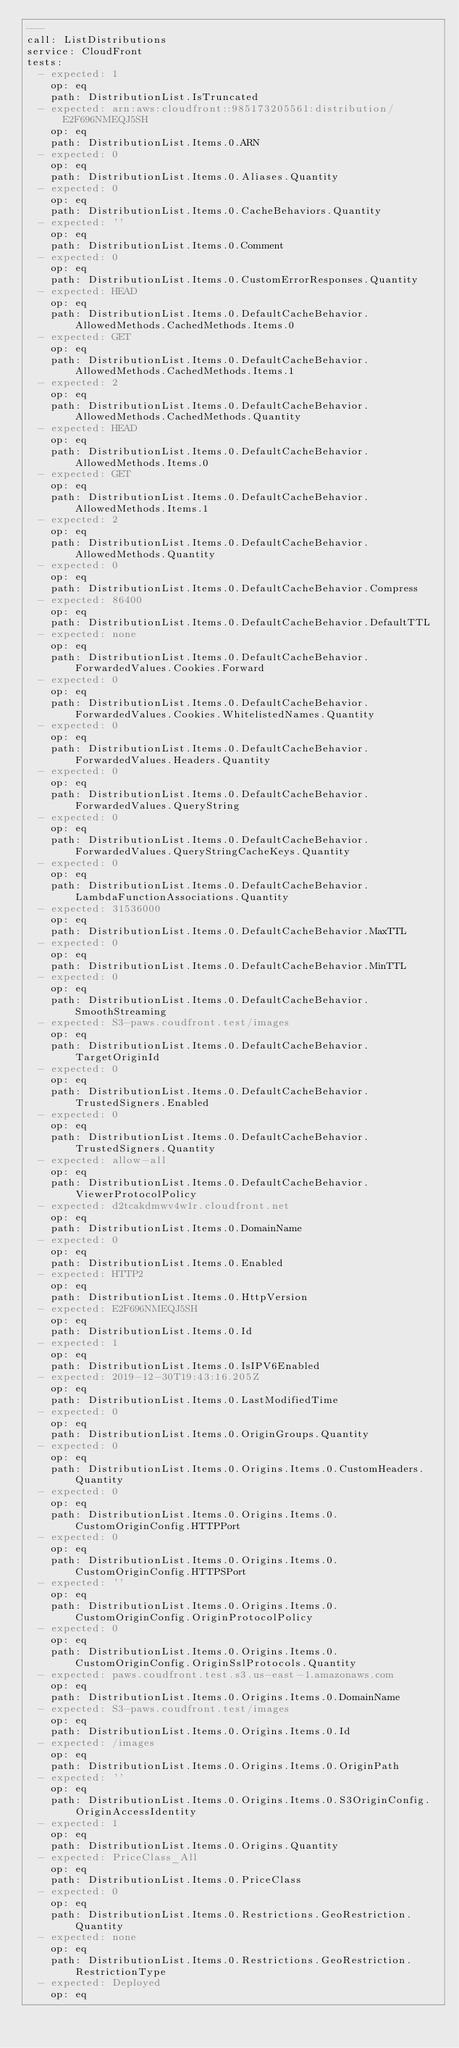<code> <loc_0><loc_0><loc_500><loc_500><_YAML_>---
call: ListDistributions
service: CloudFront
tests:
  - expected: 1
    op: eq
    path: DistributionList.IsTruncated
  - expected: arn:aws:cloudfront::985173205561:distribution/E2F696NMEQJ5SH
    op: eq
    path: DistributionList.Items.0.ARN
  - expected: 0
    op: eq
    path: DistributionList.Items.0.Aliases.Quantity
  - expected: 0
    op: eq
    path: DistributionList.Items.0.CacheBehaviors.Quantity
  - expected: ''
    op: eq
    path: DistributionList.Items.0.Comment
  - expected: 0
    op: eq
    path: DistributionList.Items.0.CustomErrorResponses.Quantity
  - expected: HEAD
    op: eq
    path: DistributionList.Items.0.DefaultCacheBehavior.AllowedMethods.CachedMethods.Items.0
  - expected: GET
    op: eq
    path: DistributionList.Items.0.DefaultCacheBehavior.AllowedMethods.CachedMethods.Items.1
  - expected: 2
    op: eq
    path: DistributionList.Items.0.DefaultCacheBehavior.AllowedMethods.CachedMethods.Quantity
  - expected: HEAD
    op: eq
    path: DistributionList.Items.0.DefaultCacheBehavior.AllowedMethods.Items.0
  - expected: GET
    op: eq
    path: DistributionList.Items.0.DefaultCacheBehavior.AllowedMethods.Items.1
  - expected: 2
    op: eq
    path: DistributionList.Items.0.DefaultCacheBehavior.AllowedMethods.Quantity
  - expected: 0
    op: eq
    path: DistributionList.Items.0.DefaultCacheBehavior.Compress
  - expected: 86400
    op: eq
    path: DistributionList.Items.0.DefaultCacheBehavior.DefaultTTL
  - expected: none
    op: eq
    path: DistributionList.Items.0.DefaultCacheBehavior.ForwardedValues.Cookies.Forward
  - expected: 0
    op: eq
    path: DistributionList.Items.0.DefaultCacheBehavior.ForwardedValues.Cookies.WhitelistedNames.Quantity
  - expected: 0
    op: eq
    path: DistributionList.Items.0.DefaultCacheBehavior.ForwardedValues.Headers.Quantity
  - expected: 0
    op: eq
    path: DistributionList.Items.0.DefaultCacheBehavior.ForwardedValues.QueryString
  - expected: 0
    op: eq
    path: DistributionList.Items.0.DefaultCacheBehavior.ForwardedValues.QueryStringCacheKeys.Quantity
  - expected: 0
    op: eq
    path: DistributionList.Items.0.DefaultCacheBehavior.LambdaFunctionAssociations.Quantity
  - expected: 31536000
    op: eq
    path: DistributionList.Items.0.DefaultCacheBehavior.MaxTTL
  - expected: 0
    op: eq
    path: DistributionList.Items.0.DefaultCacheBehavior.MinTTL
  - expected: 0
    op: eq
    path: DistributionList.Items.0.DefaultCacheBehavior.SmoothStreaming
  - expected: S3-paws.coudfront.test/images
    op: eq
    path: DistributionList.Items.0.DefaultCacheBehavior.TargetOriginId
  - expected: 0
    op: eq
    path: DistributionList.Items.0.DefaultCacheBehavior.TrustedSigners.Enabled
  - expected: 0
    op: eq
    path: DistributionList.Items.0.DefaultCacheBehavior.TrustedSigners.Quantity
  - expected: allow-all
    op: eq
    path: DistributionList.Items.0.DefaultCacheBehavior.ViewerProtocolPolicy
  - expected: d2tcakdmwv4w1r.cloudfront.net
    op: eq
    path: DistributionList.Items.0.DomainName
  - expected: 0
    op: eq
    path: DistributionList.Items.0.Enabled
  - expected: HTTP2
    op: eq
    path: DistributionList.Items.0.HttpVersion
  - expected: E2F696NMEQJ5SH
    op: eq
    path: DistributionList.Items.0.Id
  - expected: 1
    op: eq
    path: DistributionList.Items.0.IsIPV6Enabled
  - expected: 2019-12-30T19:43:16.205Z
    op: eq
    path: DistributionList.Items.0.LastModifiedTime
  - expected: 0
    op: eq
    path: DistributionList.Items.0.OriginGroups.Quantity
  - expected: 0
    op: eq
    path: DistributionList.Items.0.Origins.Items.0.CustomHeaders.Quantity
  - expected: 0
    op: eq
    path: DistributionList.Items.0.Origins.Items.0.CustomOriginConfig.HTTPPort
  - expected: 0
    op: eq
    path: DistributionList.Items.0.Origins.Items.0.CustomOriginConfig.HTTPSPort
  - expected: ''
    op: eq
    path: DistributionList.Items.0.Origins.Items.0.CustomOriginConfig.OriginProtocolPolicy
  - expected: 0
    op: eq
    path: DistributionList.Items.0.Origins.Items.0.CustomOriginConfig.OriginSslProtocols.Quantity
  - expected: paws.coudfront.test.s3.us-east-1.amazonaws.com
    op: eq
    path: DistributionList.Items.0.Origins.Items.0.DomainName
  - expected: S3-paws.coudfront.test/images
    op: eq
    path: DistributionList.Items.0.Origins.Items.0.Id
  - expected: /images
    op: eq
    path: DistributionList.Items.0.Origins.Items.0.OriginPath
  - expected: ''
    op: eq
    path: DistributionList.Items.0.Origins.Items.0.S3OriginConfig.OriginAccessIdentity
  - expected: 1
    op: eq
    path: DistributionList.Items.0.Origins.Quantity
  - expected: PriceClass_All
    op: eq
    path: DistributionList.Items.0.PriceClass
  - expected: 0
    op: eq
    path: DistributionList.Items.0.Restrictions.GeoRestriction.Quantity
  - expected: none
    op: eq
    path: DistributionList.Items.0.Restrictions.GeoRestriction.RestrictionType
  - expected: Deployed
    op: eq</code> 